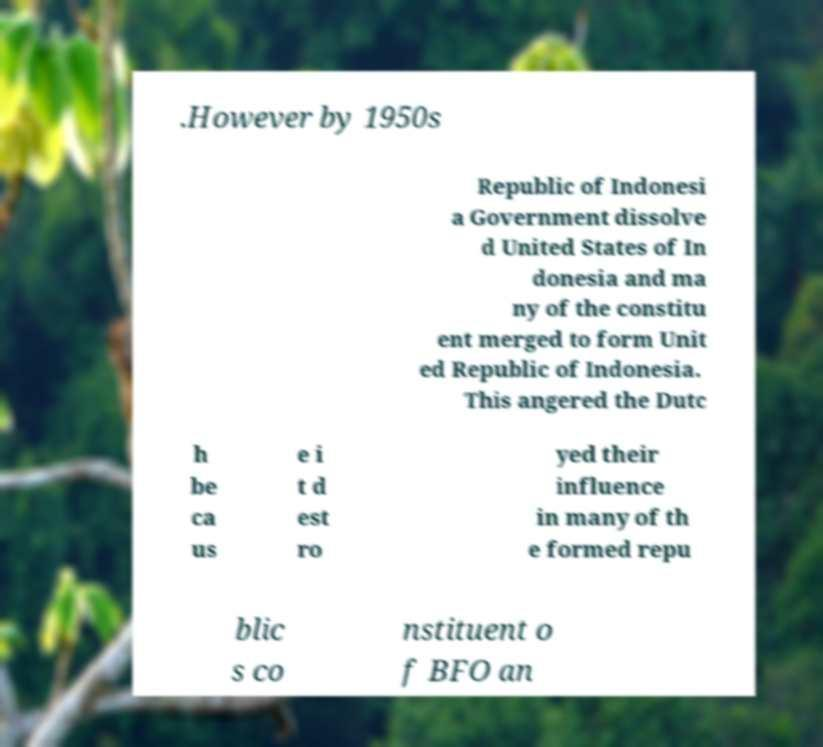Could you extract and type out the text from this image? .However by 1950s Republic of Indonesi a Government dissolve d United States of In donesia and ma ny of the constitu ent merged to form Unit ed Republic of Indonesia. This angered the Dutc h be ca us e i t d est ro yed their influence in many of th e formed repu blic s co nstituent o f BFO an 